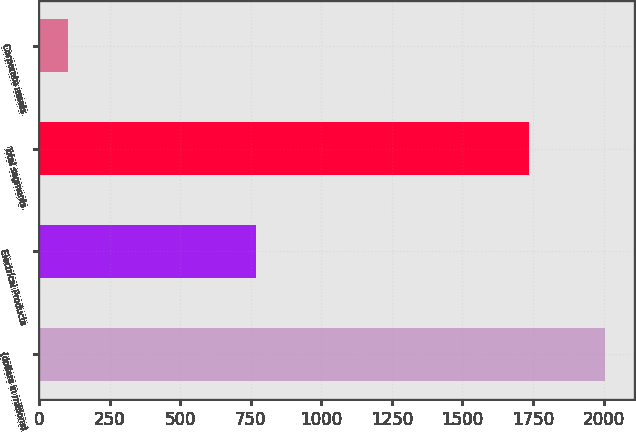Convert chart to OTSL. <chart><loc_0><loc_0><loc_500><loc_500><bar_chart><fcel>(dollars in millions)<fcel>Electrical Products<fcel>Total segments<fcel>Corporate assets<nl><fcel>2006<fcel>768.2<fcel>1735.4<fcel>104.5<nl></chart> 